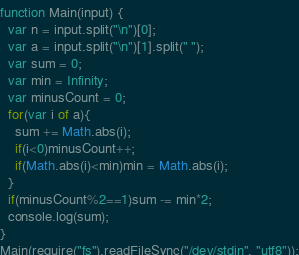<code> <loc_0><loc_0><loc_500><loc_500><_JavaScript_>function Main(input) {
  var n = input.split("\n")[0];
  var a = input.split("\n")[1].split(" ");
  var sum = 0;
  var min = Infinity;
  var minusCount = 0;
  for(var i of a){
  	sum += Math.abs(i);
    if(i<0)minusCount++;
    if(Math.abs(i)<min)min = Math.abs(i);
  }
  if(minusCount%2==1)sum -= min*2;
  console.log(sum);
}
Main(require("fs").readFileSync("/dev/stdin", "utf8"));</code> 